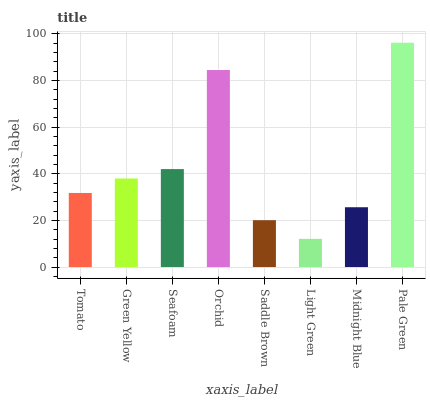Is Light Green the minimum?
Answer yes or no. Yes. Is Pale Green the maximum?
Answer yes or no. Yes. Is Green Yellow the minimum?
Answer yes or no. No. Is Green Yellow the maximum?
Answer yes or no. No. Is Green Yellow greater than Tomato?
Answer yes or no. Yes. Is Tomato less than Green Yellow?
Answer yes or no. Yes. Is Tomato greater than Green Yellow?
Answer yes or no. No. Is Green Yellow less than Tomato?
Answer yes or no. No. Is Green Yellow the high median?
Answer yes or no. Yes. Is Tomato the low median?
Answer yes or no. Yes. Is Midnight Blue the high median?
Answer yes or no. No. Is Orchid the low median?
Answer yes or no. No. 